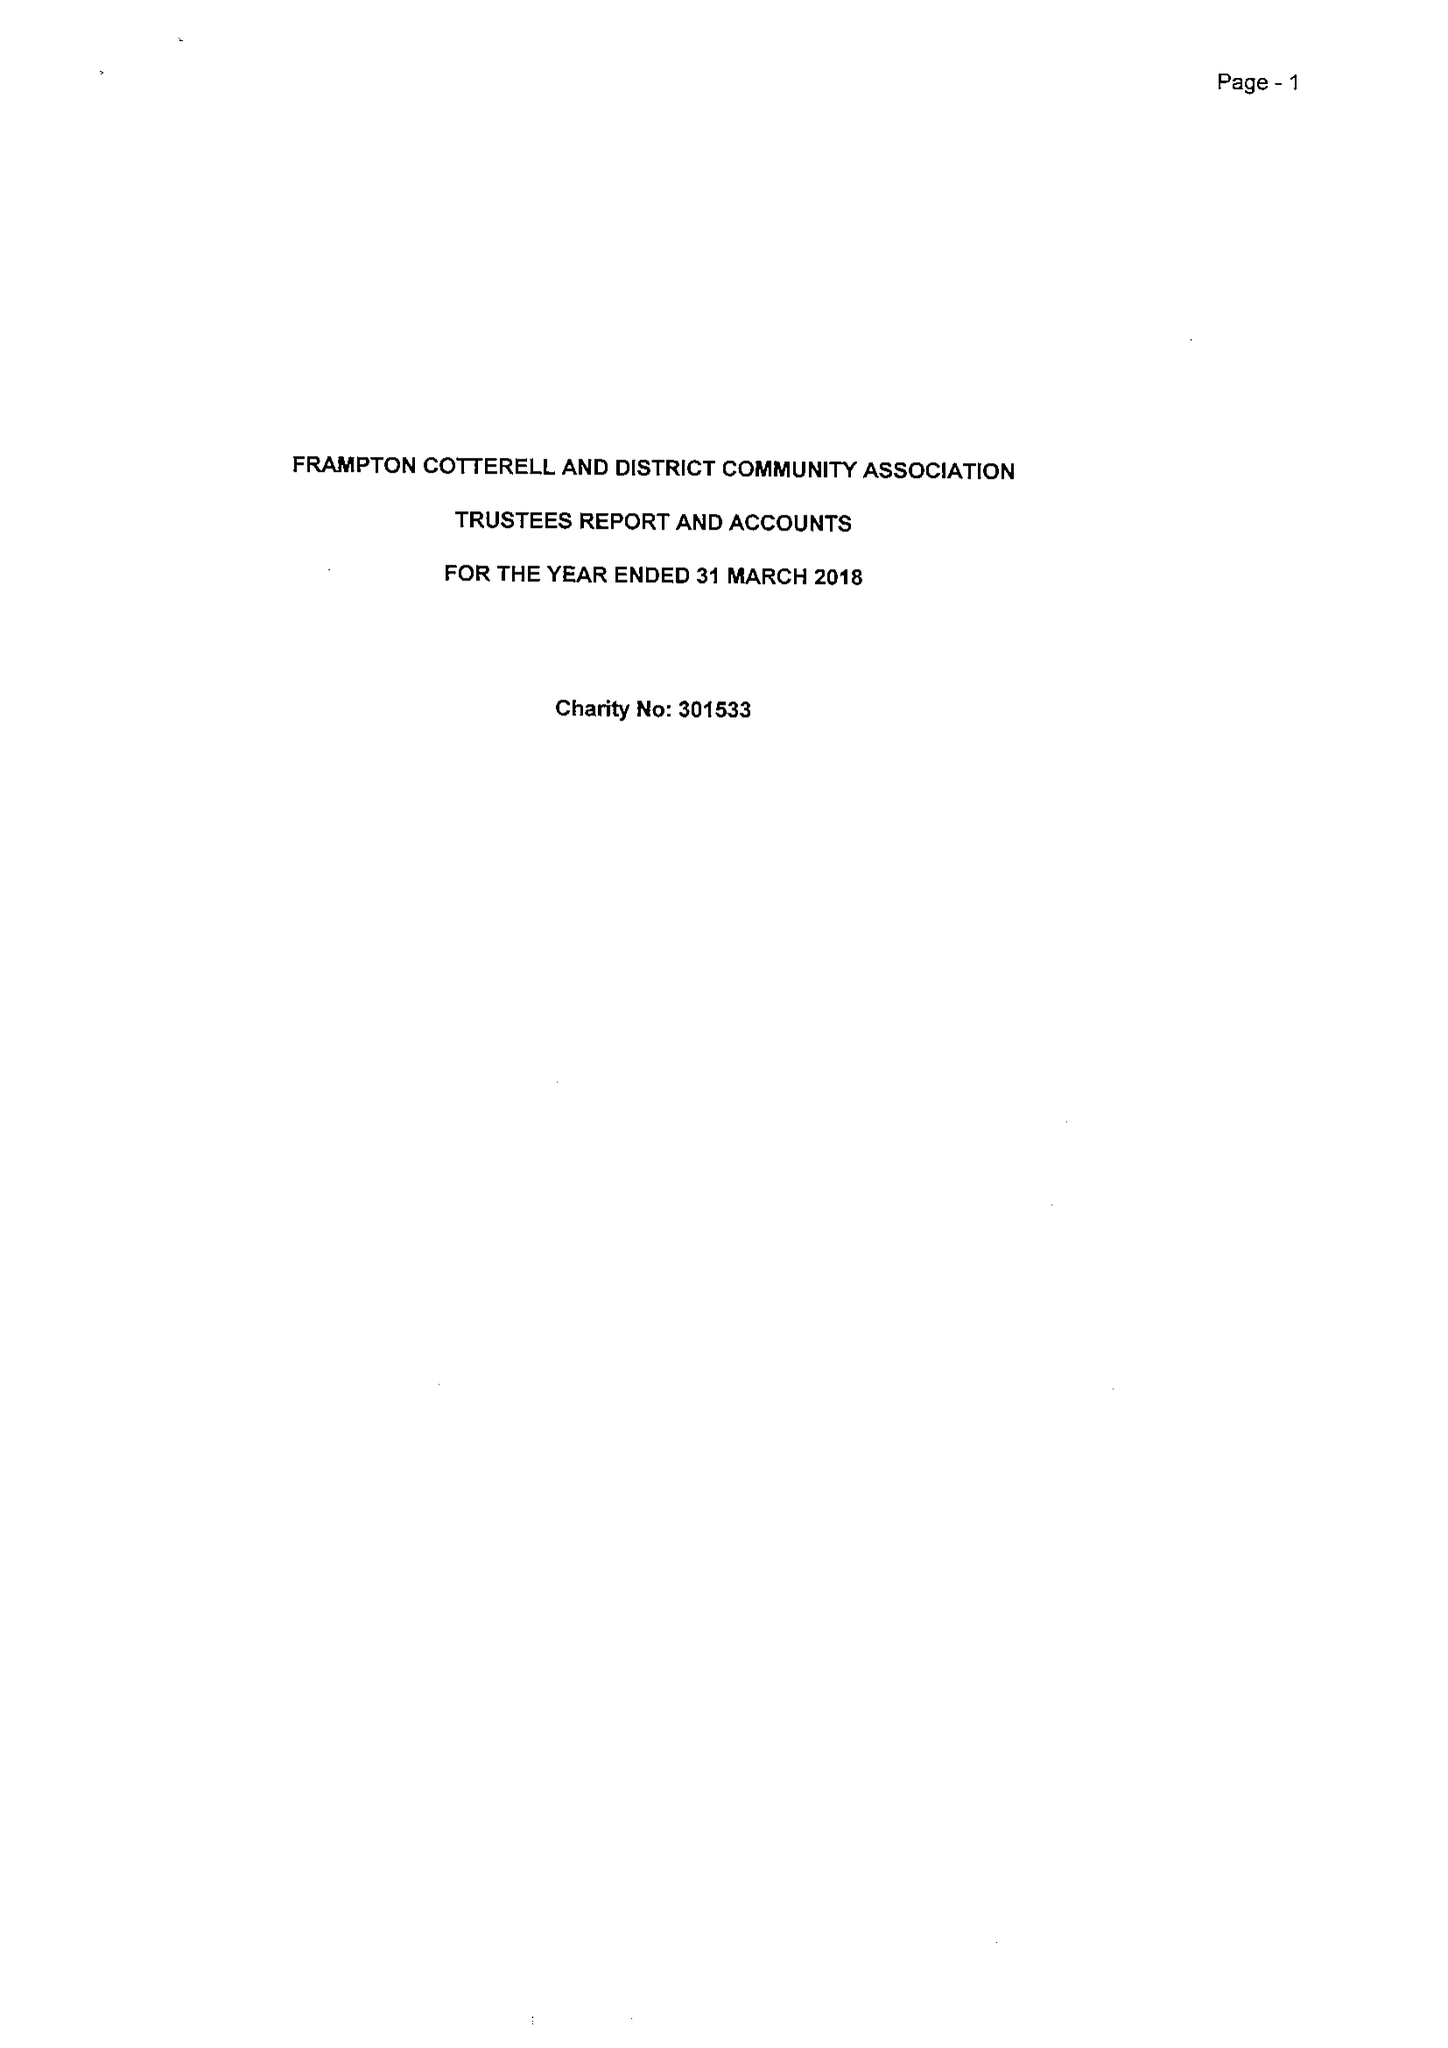What is the value for the report_date?
Answer the question using a single word or phrase. 2018-03-31 